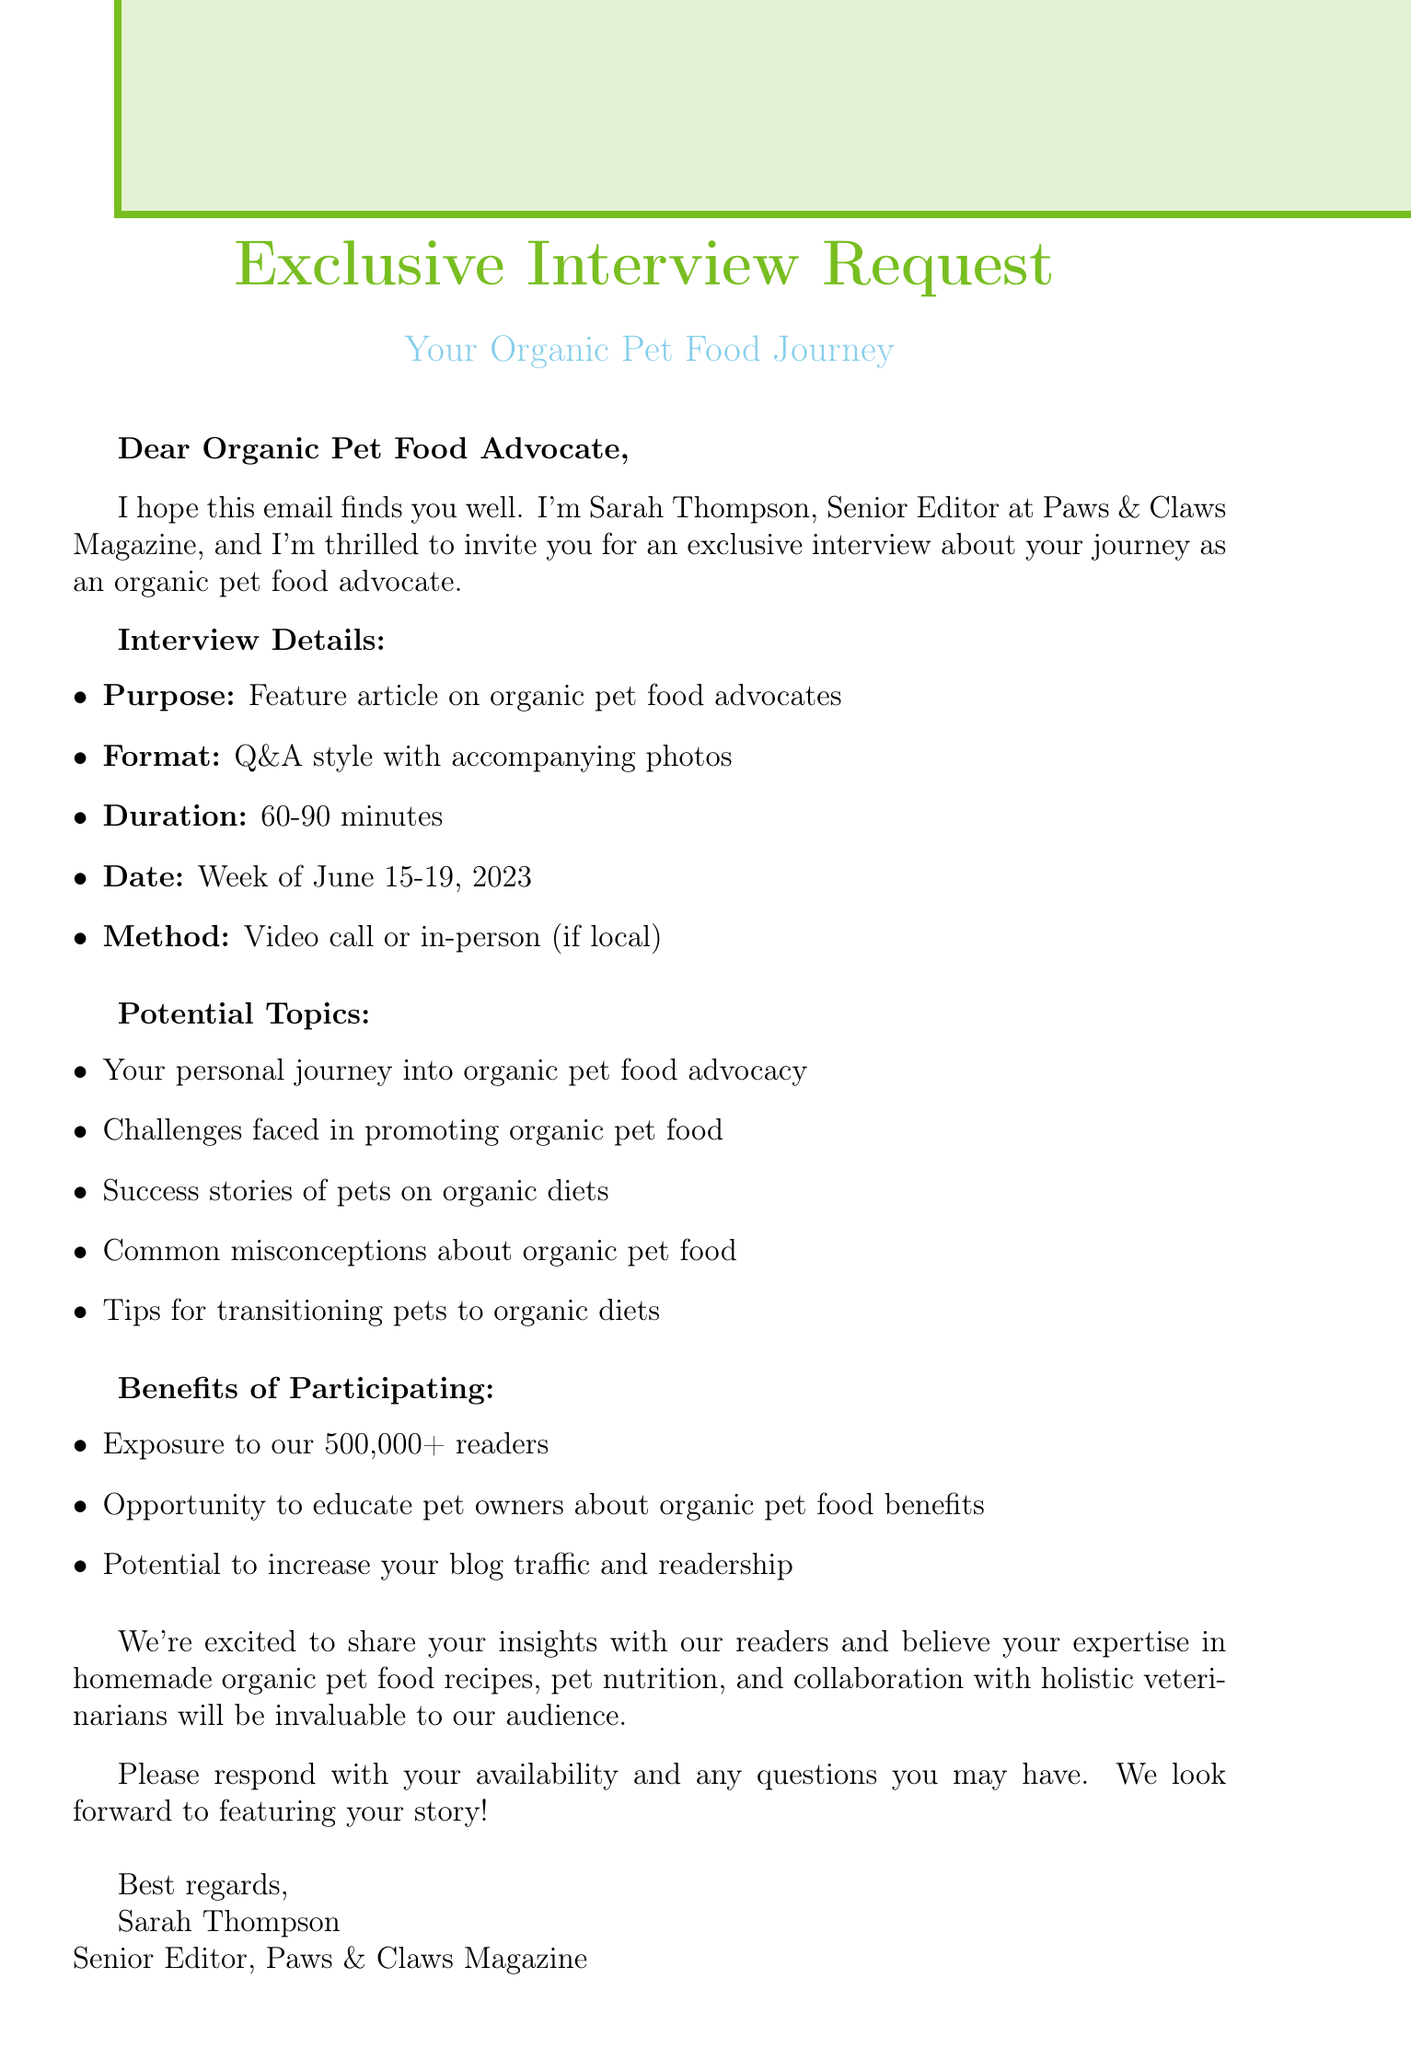What is the email subject? The subject line is explicitly mentioned at the beginning of the document as the email's title.
Answer: Exclusive Interview Request: Your Organic Pet Food Journey Who is the Senior Editor of Paws & Claws Magazine? The name of the Senior Editor is provided in the editor's information section of the document.
Answer: Sarah Thompson What type of interview format is proposed? The document specifies the format of the interview in the interview request details.
Answer: Q&A style interview What is the proposed week for the interview? The proposed date for the interview is stated in the practical details section of the document.
Answer: Week of June 15-19, 2023 How long is the estimated duration of the interview? The estimated duration is listed in the practical details section and provides a specific time frame.
Answer: 60-90 minutes What is one of the benefits of participating in the interview? The benefits are clearly outlined in a specific section of the email, providing value for participation.
Answer: Exposure to Paws & Claws Magazine's 500,000+ readers What are pets on organic diets required to be successful? Understanding the success stories helps emphasize the advantages of organic diets discussed in the document.
Answer: Success stories of pets on organic diets What common misconception about organic pet food could you discuss? This question references the misconceptions topic listed as one of the potential discussion points during the interview.
Answer: Common misconceptions about organic pet food 